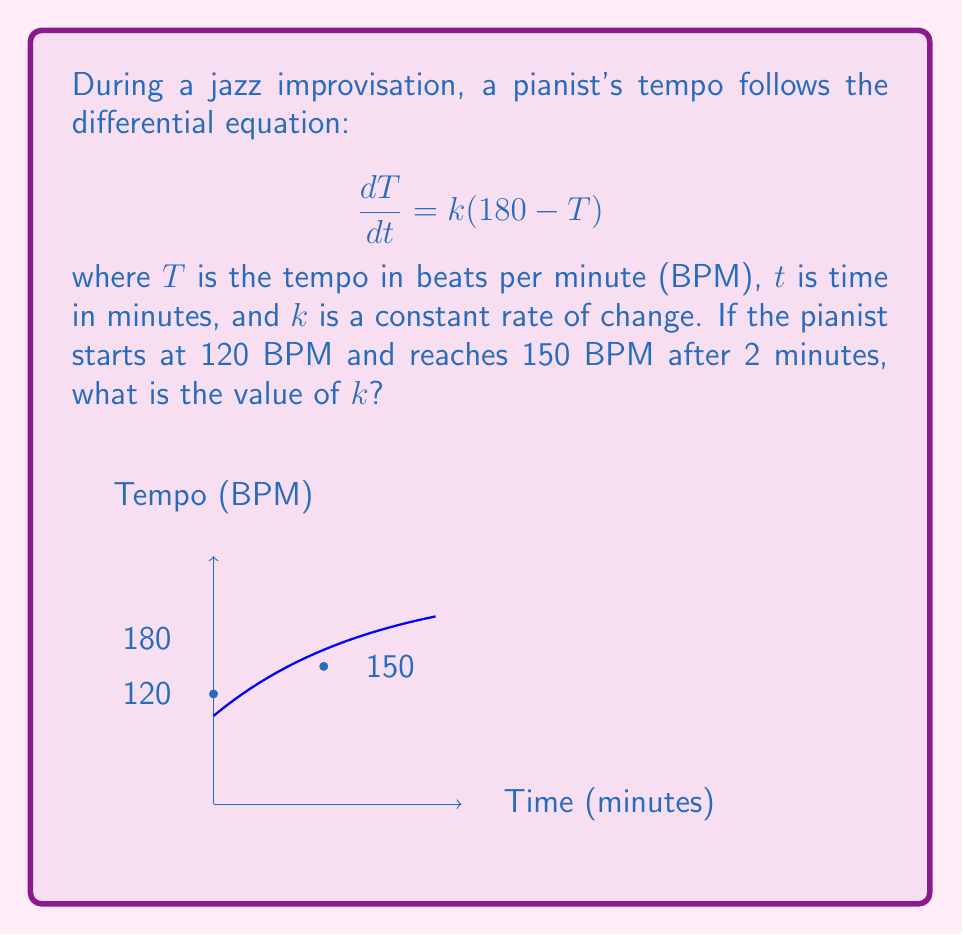Give your solution to this math problem. Let's solve this step-by-step:

1) The given differential equation is a first-order linear differential equation:
   $$\frac{dT}{dt} = k(180 - T)$$

2) The general solution for this type of equation is:
   $$T = 180 - Ce^{-kt}$$
   where $C$ is a constant of integration.

3) We know the initial condition: when $t=0$, $T=120$. Let's use this to find $C$:
   $$120 = 180 - Ce^{-k(0)}$$
   $$120 = 180 - C$$
   $$C = 60$$

4) So our specific solution is:
   $$T = 180 - 60e^{-kt}$$

5) Now we can use the second condition: when $t=2$, $T=150$:
   $$150 = 180 - 60e^{-k(2)}$$

6) Solving for $e^{-2k}$:
   $$60e^{-2k} = 30$$
   $$e^{-2k} = \frac{1}{2}$$

7) Taking the natural log of both sides:
   $$-2k = \ln(\frac{1}{2}) = -\ln(2)$$

8) Solving for $k$:
   $$k = \frac{\ln(2)}{2} \approx 0.3466$$

Therefore, the value of $k$ is approximately 0.3466 per minute.
Answer: $k \approx 0.3466$ per minute 